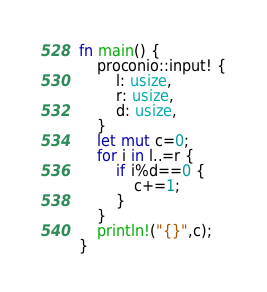<code> <loc_0><loc_0><loc_500><loc_500><_Rust_>fn main() {
    proconio::input! {
        l: usize,
        r: usize,
        d: usize,
    }
    let mut c=0;
    for i in l..=r {
        if i%d==0 {
            c+=1;
        }
    }
    println!("{}",c);
}</code> 